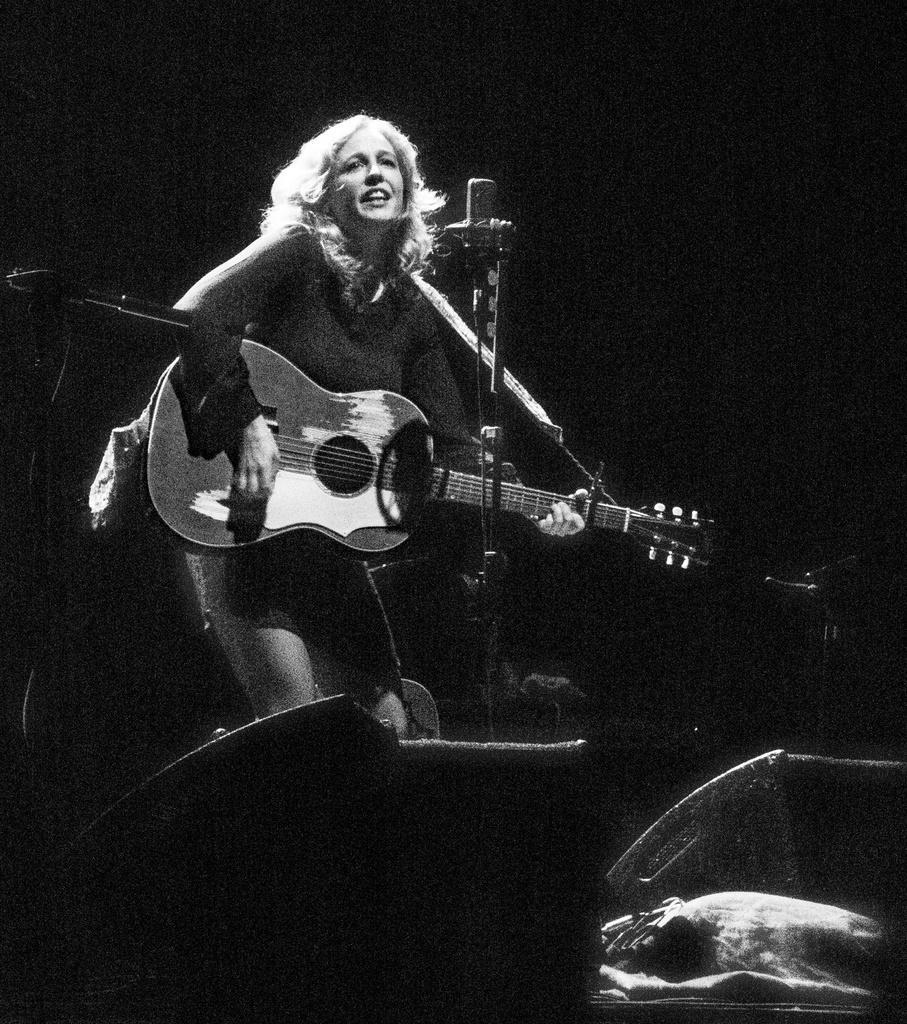In one or two sentences, can you explain what this image depicts? In this image I see a woman who is standing and she is holding a guitar in her hands and there is a mic in front of her. 